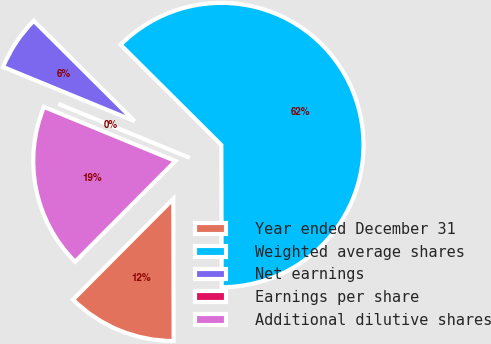Convert chart. <chart><loc_0><loc_0><loc_500><loc_500><pie_chart><fcel>Year ended December 31<fcel>Weighted average shares<fcel>Net earnings<fcel>Earnings per share<fcel>Additional dilutive shares<nl><fcel>12.5%<fcel>62.5%<fcel>6.25%<fcel>0.0%<fcel>18.75%<nl></chart> 